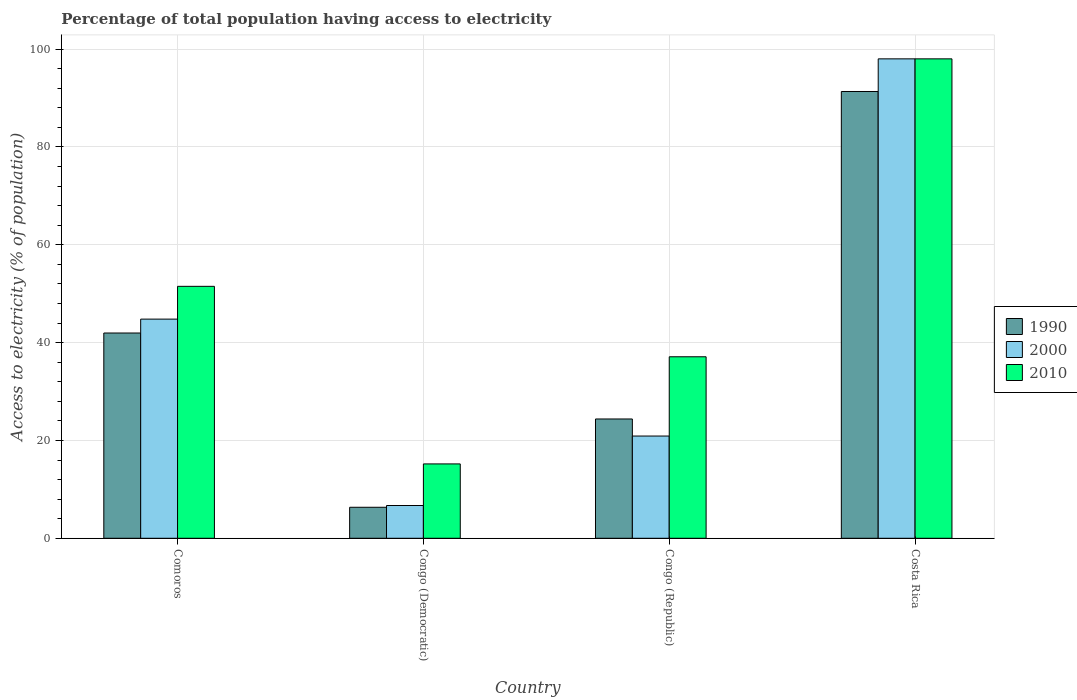How many different coloured bars are there?
Give a very brief answer. 3. Are the number of bars on each tick of the X-axis equal?
Your answer should be very brief. Yes. What is the label of the 2nd group of bars from the left?
Your answer should be very brief. Congo (Democratic). What is the percentage of population that have access to electricity in 1990 in Costa Rica?
Your answer should be very brief. 91.33. Across all countries, what is the maximum percentage of population that have access to electricity in 2000?
Provide a short and direct response. 98. Across all countries, what is the minimum percentage of population that have access to electricity in 2010?
Ensure brevity in your answer.  15.2. In which country was the percentage of population that have access to electricity in 1990 minimum?
Your response must be concise. Congo (Democratic). What is the total percentage of population that have access to electricity in 2000 in the graph?
Your answer should be compact. 170.4. What is the difference between the percentage of population that have access to electricity in 2010 in Comoros and that in Congo (Republic)?
Ensure brevity in your answer.  14.4. What is the difference between the percentage of population that have access to electricity in 1990 in Congo (Republic) and the percentage of population that have access to electricity in 2000 in Comoros?
Provide a short and direct response. -20.41. What is the average percentage of population that have access to electricity in 1990 per country?
Give a very brief answer. 41. What is the difference between the percentage of population that have access to electricity of/in 1990 and percentage of population that have access to electricity of/in 2010 in Congo (Republic)?
Your answer should be very brief. -12.71. In how many countries, is the percentage of population that have access to electricity in 1990 greater than 88 %?
Offer a terse response. 1. What is the ratio of the percentage of population that have access to electricity in 2000 in Congo (Democratic) to that in Costa Rica?
Offer a very short reply. 0.07. Is the difference between the percentage of population that have access to electricity in 1990 in Congo (Republic) and Costa Rica greater than the difference between the percentage of population that have access to electricity in 2010 in Congo (Republic) and Costa Rica?
Keep it short and to the point. No. What is the difference between the highest and the second highest percentage of population that have access to electricity in 1990?
Ensure brevity in your answer.  -17.57. What is the difference between the highest and the lowest percentage of population that have access to electricity in 2010?
Give a very brief answer. 82.8. What does the 2nd bar from the left in Congo (Democratic) represents?
Give a very brief answer. 2000. What does the 2nd bar from the right in Congo (Democratic) represents?
Your response must be concise. 2000. Are all the bars in the graph horizontal?
Ensure brevity in your answer.  No. What is the difference between two consecutive major ticks on the Y-axis?
Make the answer very short. 20. Are the values on the major ticks of Y-axis written in scientific E-notation?
Give a very brief answer. No. Does the graph contain any zero values?
Make the answer very short. No. How many legend labels are there?
Offer a very short reply. 3. How are the legend labels stacked?
Give a very brief answer. Vertical. What is the title of the graph?
Offer a very short reply. Percentage of total population having access to electricity. Does "1976" appear as one of the legend labels in the graph?
Provide a succinct answer. No. What is the label or title of the Y-axis?
Provide a succinct answer. Access to electricity (% of population). What is the Access to electricity (% of population) of 1990 in Comoros?
Make the answer very short. 41.96. What is the Access to electricity (% of population) of 2000 in Comoros?
Make the answer very short. 44.8. What is the Access to electricity (% of population) of 2010 in Comoros?
Ensure brevity in your answer.  51.5. What is the Access to electricity (% of population) of 1990 in Congo (Democratic)?
Ensure brevity in your answer.  6.34. What is the Access to electricity (% of population) in 2010 in Congo (Democratic)?
Ensure brevity in your answer.  15.2. What is the Access to electricity (% of population) of 1990 in Congo (Republic)?
Your response must be concise. 24.39. What is the Access to electricity (% of population) in 2000 in Congo (Republic)?
Offer a terse response. 20.9. What is the Access to electricity (% of population) of 2010 in Congo (Republic)?
Offer a terse response. 37.1. What is the Access to electricity (% of population) of 1990 in Costa Rica?
Keep it short and to the point. 91.33. What is the Access to electricity (% of population) in 2000 in Costa Rica?
Ensure brevity in your answer.  98. Across all countries, what is the maximum Access to electricity (% of population) of 1990?
Offer a very short reply. 91.33. Across all countries, what is the maximum Access to electricity (% of population) in 2010?
Your answer should be very brief. 98. Across all countries, what is the minimum Access to electricity (% of population) in 1990?
Give a very brief answer. 6.34. Across all countries, what is the minimum Access to electricity (% of population) of 2010?
Ensure brevity in your answer.  15.2. What is the total Access to electricity (% of population) in 1990 in the graph?
Keep it short and to the point. 164.01. What is the total Access to electricity (% of population) of 2000 in the graph?
Give a very brief answer. 170.4. What is the total Access to electricity (% of population) of 2010 in the graph?
Provide a short and direct response. 201.8. What is the difference between the Access to electricity (% of population) of 1990 in Comoros and that in Congo (Democratic)?
Provide a short and direct response. 35.62. What is the difference between the Access to electricity (% of population) in 2000 in Comoros and that in Congo (Democratic)?
Your response must be concise. 38.1. What is the difference between the Access to electricity (% of population) in 2010 in Comoros and that in Congo (Democratic)?
Make the answer very short. 36.3. What is the difference between the Access to electricity (% of population) of 1990 in Comoros and that in Congo (Republic)?
Ensure brevity in your answer.  17.57. What is the difference between the Access to electricity (% of population) in 2000 in Comoros and that in Congo (Republic)?
Provide a short and direct response. 23.9. What is the difference between the Access to electricity (% of population) in 1990 in Comoros and that in Costa Rica?
Make the answer very short. -49.37. What is the difference between the Access to electricity (% of population) of 2000 in Comoros and that in Costa Rica?
Give a very brief answer. -53.2. What is the difference between the Access to electricity (% of population) in 2010 in Comoros and that in Costa Rica?
Provide a succinct answer. -46.5. What is the difference between the Access to electricity (% of population) of 1990 in Congo (Democratic) and that in Congo (Republic)?
Offer a very short reply. -18.05. What is the difference between the Access to electricity (% of population) of 2000 in Congo (Democratic) and that in Congo (Republic)?
Provide a succinct answer. -14.2. What is the difference between the Access to electricity (% of population) of 2010 in Congo (Democratic) and that in Congo (Republic)?
Your answer should be compact. -21.9. What is the difference between the Access to electricity (% of population) of 1990 in Congo (Democratic) and that in Costa Rica?
Give a very brief answer. -84.99. What is the difference between the Access to electricity (% of population) in 2000 in Congo (Democratic) and that in Costa Rica?
Provide a short and direct response. -91.3. What is the difference between the Access to electricity (% of population) of 2010 in Congo (Democratic) and that in Costa Rica?
Provide a succinct answer. -82.8. What is the difference between the Access to electricity (% of population) in 1990 in Congo (Republic) and that in Costa Rica?
Offer a terse response. -66.94. What is the difference between the Access to electricity (% of population) of 2000 in Congo (Republic) and that in Costa Rica?
Your response must be concise. -77.1. What is the difference between the Access to electricity (% of population) in 2010 in Congo (Republic) and that in Costa Rica?
Offer a very short reply. -60.9. What is the difference between the Access to electricity (% of population) of 1990 in Comoros and the Access to electricity (% of population) of 2000 in Congo (Democratic)?
Your answer should be compact. 35.26. What is the difference between the Access to electricity (% of population) of 1990 in Comoros and the Access to electricity (% of population) of 2010 in Congo (Democratic)?
Provide a short and direct response. 26.76. What is the difference between the Access to electricity (% of population) in 2000 in Comoros and the Access to electricity (% of population) in 2010 in Congo (Democratic)?
Ensure brevity in your answer.  29.6. What is the difference between the Access to electricity (% of population) in 1990 in Comoros and the Access to electricity (% of population) in 2000 in Congo (Republic)?
Provide a succinct answer. 21.06. What is the difference between the Access to electricity (% of population) in 1990 in Comoros and the Access to electricity (% of population) in 2010 in Congo (Republic)?
Provide a short and direct response. 4.86. What is the difference between the Access to electricity (% of population) in 2000 in Comoros and the Access to electricity (% of population) in 2010 in Congo (Republic)?
Your answer should be very brief. 7.7. What is the difference between the Access to electricity (% of population) in 1990 in Comoros and the Access to electricity (% of population) in 2000 in Costa Rica?
Provide a short and direct response. -56.04. What is the difference between the Access to electricity (% of population) in 1990 in Comoros and the Access to electricity (% of population) in 2010 in Costa Rica?
Your answer should be compact. -56.04. What is the difference between the Access to electricity (% of population) of 2000 in Comoros and the Access to electricity (% of population) of 2010 in Costa Rica?
Ensure brevity in your answer.  -53.2. What is the difference between the Access to electricity (% of population) of 1990 in Congo (Democratic) and the Access to electricity (% of population) of 2000 in Congo (Republic)?
Your response must be concise. -14.56. What is the difference between the Access to electricity (% of population) of 1990 in Congo (Democratic) and the Access to electricity (% of population) of 2010 in Congo (Republic)?
Your answer should be very brief. -30.76. What is the difference between the Access to electricity (% of population) of 2000 in Congo (Democratic) and the Access to electricity (% of population) of 2010 in Congo (Republic)?
Ensure brevity in your answer.  -30.4. What is the difference between the Access to electricity (% of population) of 1990 in Congo (Democratic) and the Access to electricity (% of population) of 2000 in Costa Rica?
Offer a very short reply. -91.66. What is the difference between the Access to electricity (% of population) in 1990 in Congo (Democratic) and the Access to electricity (% of population) in 2010 in Costa Rica?
Your answer should be very brief. -91.66. What is the difference between the Access to electricity (% of population) in 2000 in Congo (Democratic) and the Access to electricity (% of population) in 2010 in Costa Rica?
Give a very brief answer. -91.3. What is the difference between the Access to electricity (% of population) in 1990 in Congo (Republic) and the Access to electricity (% of population) in 2000 in Costa Rica?
Provide a succinct answer. -73.61. What is the difference between the Access to electricity (% of population) in 1990 in Congo (Republic) and the Access to electricity (% of population) in 2010 in Costa Rica?
Your response must be concise. -73.61. What is the difference between the Access to electricity (% of population) in 2000 in Congo (Republic) and the Access to electricity (% of population) in 2010 in Costa Rica?
Make the answer very short. -77.1. What is the average Access to electricity (% of population) of 1990 per country?
Offer a very short reply. 41. What is the average Access to electricity (% of population) in 2000 per country?
Give a very brief answer. 42.6. What is the average Access to electricity (% of population) of 2010 per country?
Your answer should be compact. 50.45. What is the difference between the Access to electricity (% of population) in 1990 and Access to electricity (% of population) in 2000 in Comoros?
Make the answer very short. -2.84. What is the difference between the Access to electricity (% of population) of 1990 and Access to electricity (% of population) of 2010 in Comoros?
Give a very brief answer. -9.54. What is the difference between the Access to electricity (% of population) of 2000 and Access to electricity (% of population) of 2010 in Comoros?
Ensure brevity in your answer.  -6.7. What is the difference between the Access to electricity (% of population) in 1990 and Access to electricity (% of population) in 2000 in Congo (Democratic)?
Your answer should be compact. -0.36. What is the difference between the Access to electricity (% of population) in 1990 and Access to electricity (% of population) in 2010 in Congo (Democratic)?
Provide a short and direct response. -8.86. What is the difference between the Access to electricity (% of population) of 2000 and Access to electricity (% of population) of 2010 in Congo (Democratic)?
Give a very brief answer. -8.5. What is the difference between the Access to electricity (% of population) in 1990 and Access to electricity (% of population) in 2000 in Congo (Republic)?
Provide a succinct answer. 3.49. What is the difference between the Access to electricity (% of population) of 1990 and Access to electricity (% of population) of 2010 in Congo (Republic)?
Your response must be concise. -12.71. What is the difference between the Access to electricity (% of population) in 2000 and Access to electricity (% of population) in 2010 in Congo (Republic)?
Offer a terse response. -16.2. What is the difference between the Access to electricity (% of population) in 1990 and Access to electricity (% of population) in 2000 in Costa Rica?
Your answer should be very brief. -6.67. What is the difference between the Access to electricity (% of population) in 1990 and Access to electricity (% of population) in 2010 in Costa Rica?
Make the answer very short. -6.67. What is the difference between the Access to electricity (% of population) of 2000 and Access to electricity (% of population) of 2010 in Costa Rica?
Give a very brief answer. 0. What is the ratio of the Access to electricity (% of population) in 1990 in Comoros to that in Congo (Democratic)?
Offer a terse response. 6.62. What is the ratio of the Access to electricity (% of population) of 2000 in Comoros to that in Congo (Democratic)?
Keep it short and to the point. 6.69. What is the ratio of the Access to electricity (% of population) of 2010 in Comoros to that in Congo (Democratic)?
Give a very brief answer. 3.39. What is the ratio of the Access to electricity (% of population) in 1990 in Comoros to that in Congo (Republic)?
Offer a terse response. 1.72. What is the ratio of the Access to electricity (% of population) in 2000 in Comoros to that in Congo (Republic)?
Your answer should be compact. 2.14. What is the ratio of the Access to electricity (% of population) of 2010 in Comoros to that in Congo (Republic)?
Offer a terse response. 1.39. What is the ratio of the Access to electricity (% of population) of 1990 in Comoros to that in Costa Rica?
Your answer should be very brief. 0.46. What is the ratio of the Access to electricity (% of population) in 2000 in Comoros to that in Costa Rica?
Offer a terse response. 0.46. What is the ratio of the Access to electricity (% of population) in 2010 in Comoros to that in Costa Rica?
Offer a very short reply. 0.53. What is the ratio of the Access to electricity (% of population) of 1990 in Congo (Democratic) to that in Congo (Republic)?
Provide a succinct answer. 0.26. What is the ratio of the Access to electricity (% of population) in 2000 in Congo (Democratic) to that in Congo (Republic)?
Keep it short and to the point. 0.32. What is the ratio of the Access to electricity (% of population) of 2010 in Congo (Democratic) to that in Congo (Republic)?
Your answer should be compact. 0.41. What is the ratio of the Access to electricity (% of population) of 1990 in Congo (Democratic) to that in Costa Rica?
Keep it short and to the point. 0.07. What is the ratio of the Access to electricity (% of population) in 2000 in Congo (Democratic) to that in Costa Rica?
Keep it short and to the point. 0.07. What is the ratio of the Access to electricity (% of population) in 2010 in Congo (Democratic) to that in Costa Rica?
Your answer should be very brief. 0.16. What is the ratio of the Access to electricity (% of population) in 1990 in Congo (Republic) to that in Costa Rica?
Your answer should be compact. 0.27. What is the ratio of the Access to electricity (% of population) of 2000 in Congo (Republic) to that in Costa Rica?
Give a very brief answer. 0.21. What is the ratio of the Access to electricity (% of population) in 2010 in Congo (Republic) to that in Costa Rica?
Offer a terse response. 0.38. What is the difference between the highest and the second highest Access to electricity (% of population) in 1990?
Offer a terse response. 49.37. What is the difference between the highest and the second highest Access to electricity (% of population) of 2000?
Make the answer very short. 53.2. What is the difference between the highest and the second highest Access to electricity (% of population) of 2010?
Provide a short and direct response. 46.5. What is the difference between the highest and the lowest Access to electricity (% of population) of 1990?
Offer a terse response. 84.99. What is the difference between the highest and the lowest Access to electricity (% of population) in 2000?
Ensure brevity in your answer.  91.3. What is the difference between the highest and the lowest Access to electricity (% of population) of 2010?
Make the answer very short. 82.8. 